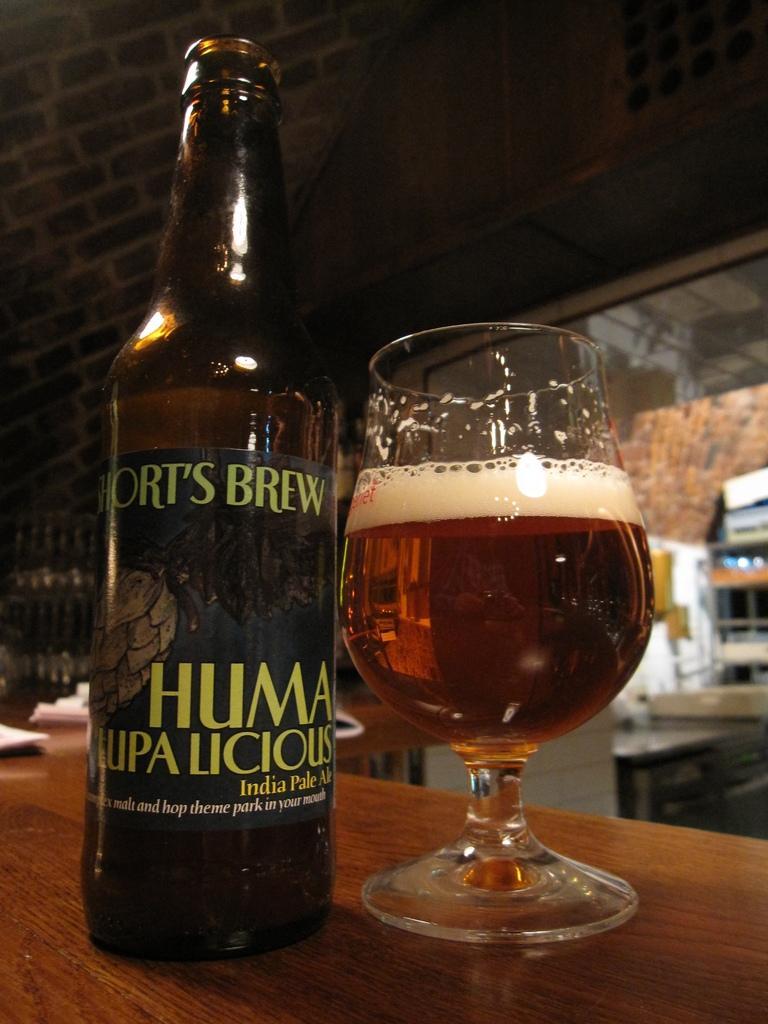Describe this image in one or two sentences. Here we can see a wine bottle and glass on the table, and here is the wall made of bricks. 